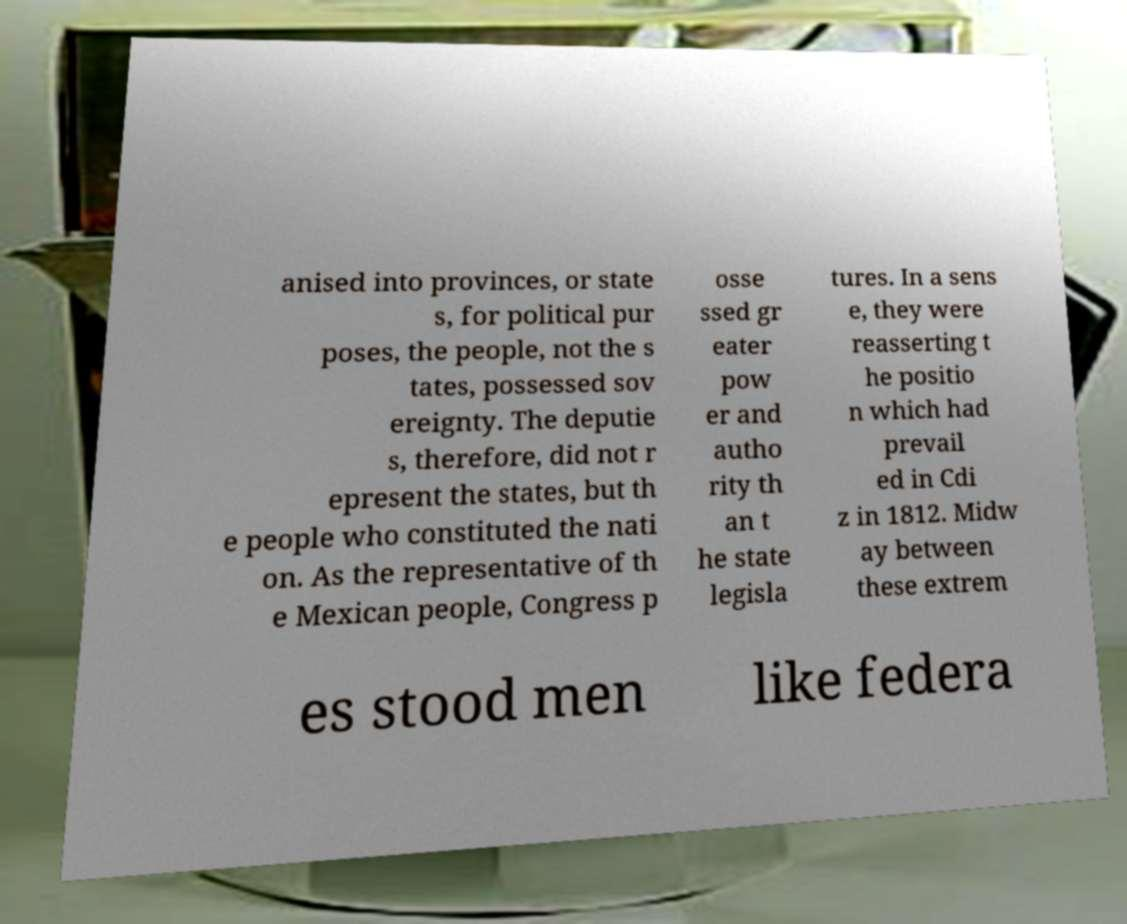Could you extract and type out the text from this image? anised into provinces, or state s, for political pur poses, the people, not the s tates, possessed sov ereignty. The deputie s, therefore, did not r epresent the states, but th e people who constituted the nati on. As the representative of th e Mexican people, Congress p osse ssed gr eater pow er and autho rity th an t he state legisla tures. In a sens e, they were reasserting t he positio n which had prevail ed in Cdi z in 1812. Midw ay between these extrem es stood men like federa 